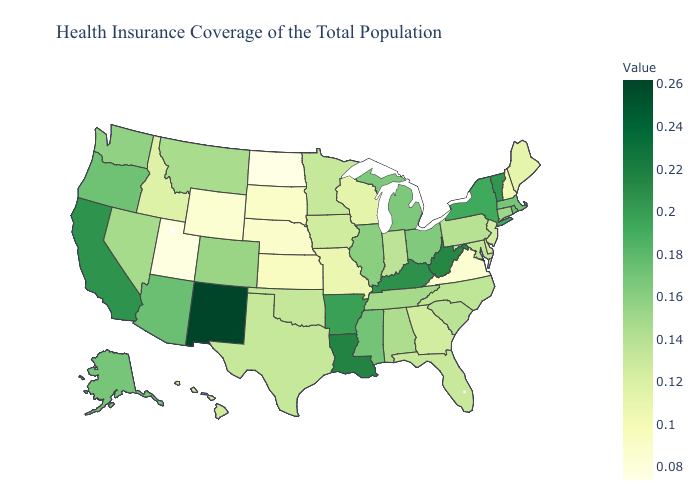Does Delaware have the lowest value in the South?
Short answer required. No. Does the map have missing data?
Concise answer only. No. Does Nevada have the lowest value in the West?
Keep it brief. No. Does Idaho have the highest value in the USA?
Concise answer only. No. Does North Dakota have the lowest value in the USA?
Give a very brief answer. Yes. Does North Dakota have the lowest value in the USA?
Quick response, please. Yes. 